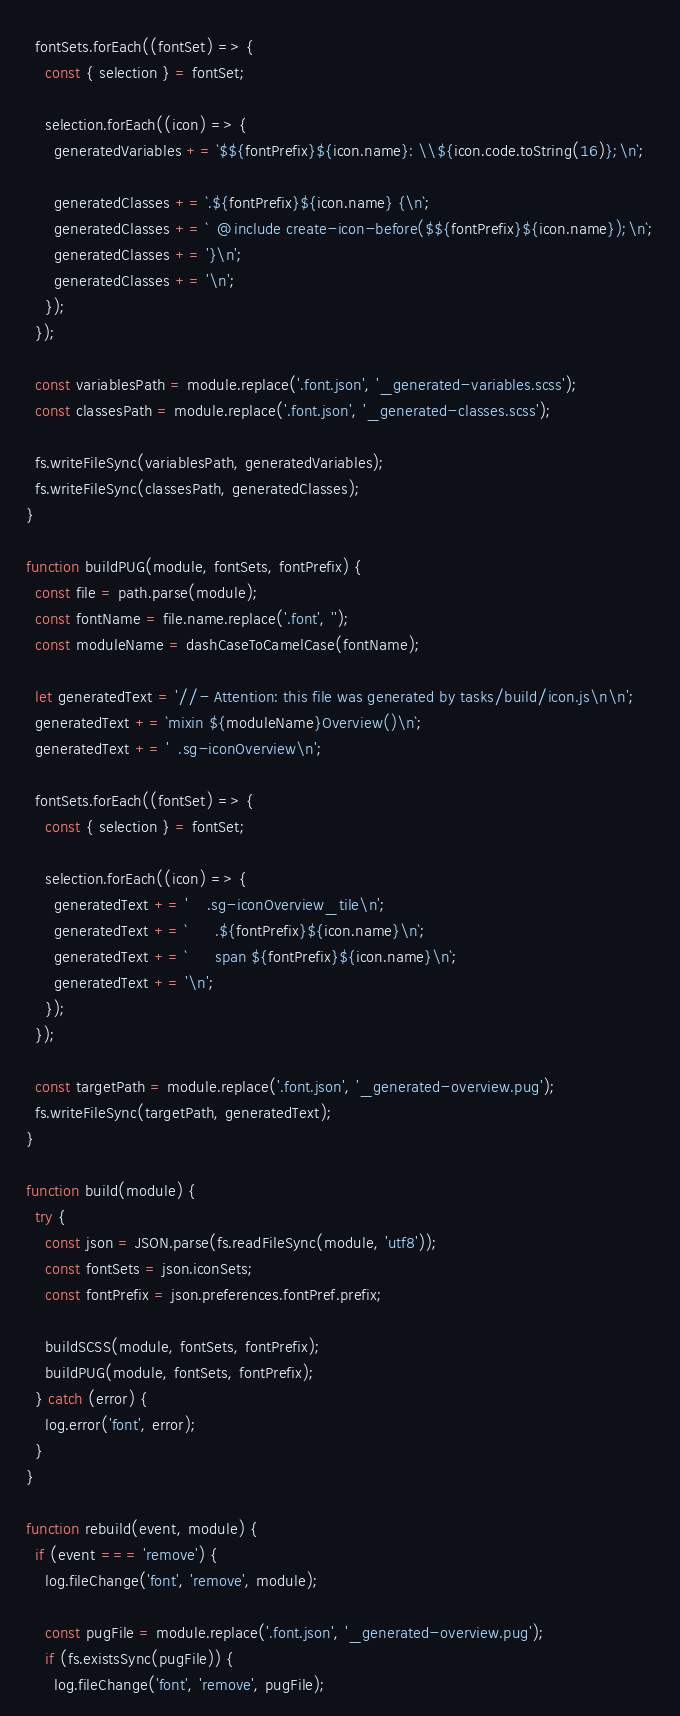Convert code to text. <code><loc_0><loc_0><loc_500><loc_500><_JavaScript_>  fontSets.forEach((fontSet) => {
    const { selection } = fontSet;

    selection.forEach((icon) => {
      generatedVariables += `$${fontPrefix}${icon.name}: \\${icon.code.toString(16)};\n`;

      generatedClasses += `.${fontPrefix}${icon.name} {\n`;
      generatedClasses += `  @include create-icon-before($${fontPrefix}${icon.name});\n`;
      generatedClasses += '}\n';
      generatedClasses += '\n';
    });
  });

  const variablesPath = module.replace('.font.json', '_generated-variables.scss');
  const classesPath = module.replace('.font.json', '_generated-classes.scss');

  fs.writeFileSync(variablesPath, generatedVariables);
  fs.writeFileSync(classesPath, generatedClasses);
}

function buildPUG(module, fontSets, fontPrefix) {
  const file = path.parse(module);
  const fontName = file.name.replace('.font', '');
  const moduleName = dashCaseToCamelCase(fontName);

  let generatedText = '//- Attention: this file was generated by tasks/build/icon.js\n\n';
  generatedText += `mixin ${moduleName}Overview()\n`;
  generatedText += '  .sg-iconOverview\n';

  fontSets.forEach((fontSet) => {
    const { selection } = fontSet;

    selection.forEach((icon) => {
      generatedText += '    .sg-iconOverview_tile\n';
      generatedText += `      .${fontPrefix}${icon.name}\n`;
      generatedText += `      span ${fontPrefix}${icon.name}\n`;
      generatedText += '\n';
    });
  });

  const targetPath = module.replace('.font.json', '_generated-overview.pug');
  fs.writeFileSync(targetPath, generatedText);
}

function build(module) {
  try {
    const json = JSON.parse(fs.readFileSync(module, 'utf8'));
    const fontSets = json.iconSets;
    const fontPrefix = json.preferences.fontPref.prefix;

    buildSCSS(module, fontSets, fontPrefix);
    buildPUG(module, fontSets, fontPrefix);
  } catch (error) {
    log.error('font', error);
  }
}

function rebuild(event, module) {
  if (event === 'remove') {
    log.fileChange('font', 'remove', module);

    const pugFile = module.replace('.font.json', '_generated-overview.pug');
    if (fs.existsSync(pugFile)) {
      log.fileChange('font', 'remove', pugFile);</code> 